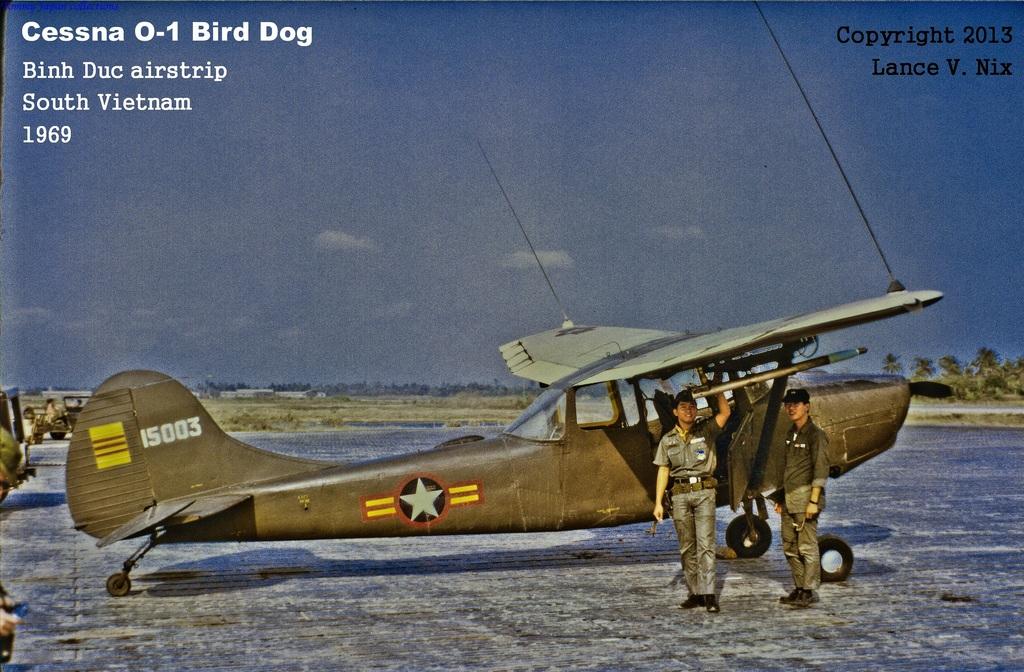How old is this plane?
Keep it short and to the point. 1969. What number is on the tail of the plane?
Give a very brief answer. 15003. 